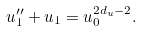<formula> <loc_0><loc_0><loc_500><loc_500>u _ { 1 } ^ { \prime \prime } + u _ { 1 } = u _ { 0 } ^ { 2 d _ { u } - 2 } .</formula> 